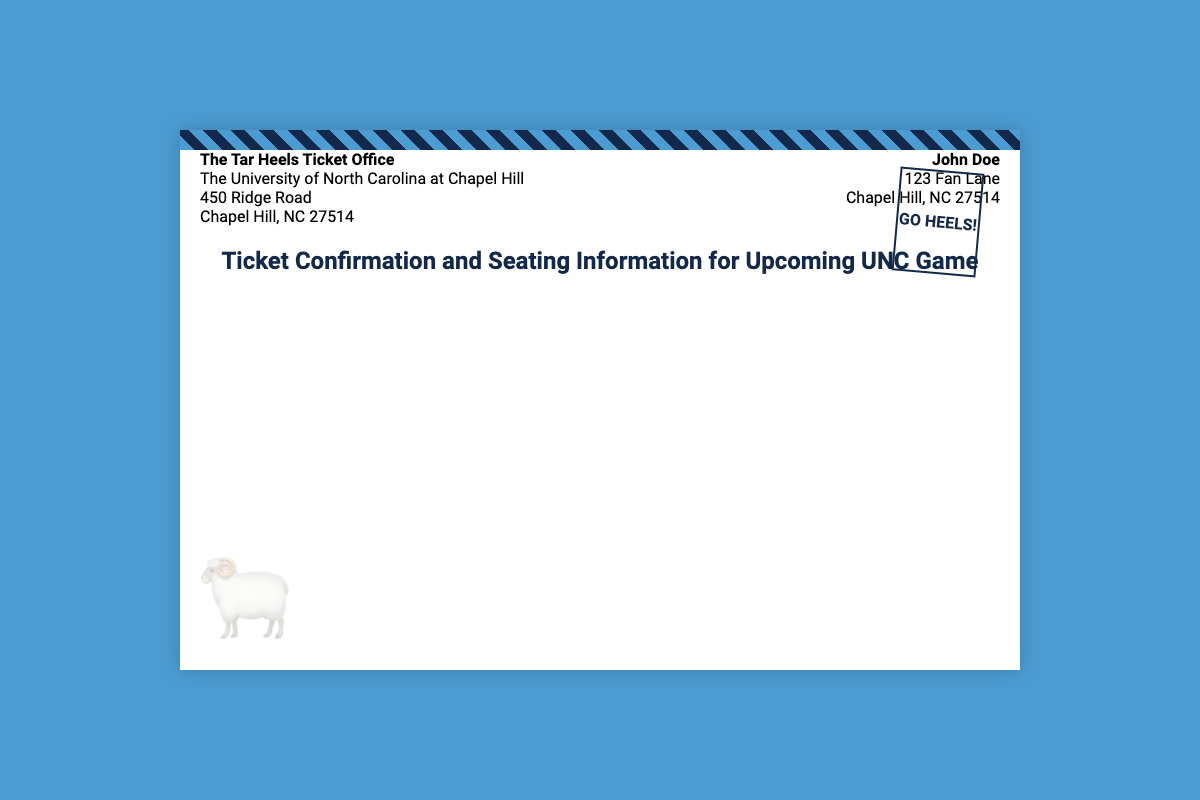What is the sender's title? The sender is identified as "The Tar Heels Ticket Office," which is the official title noted in the document.
Answer: The Tar Heels Ticket Office What is the recipient's name? The name of the person receiving the ticket is "John Doe," which is clearly stated in the address section of the document.
Answer: John Doe What is the address of the sender? The sender's address is specified as "450 Ridge Road, Chapel Hill, NC 27514," providing the location of the ticket office.
Answer: 450 Ridge Road, Chapel Hill, NC 27514 What phrase appears in the stamp? The stamp on the envelope reads "GO HEELS!" which is prominently placed for enthusiasm.
Answer: GO HEELS! What color is the background of the envelope? The background color of the envelope is "white," as described by the styling in the document.
Answer: white What decorative element is shown at the bottom of the envelope? The envelope features a logo at the bottom left, represented by an image of a ram, which is familiar to UNC fans.
Answer: logo of a ram What is the overall theme of the document? The document is themed around ticket confirmation and important information for an upcoming game, centered on supporting the University of North Carolina teams.
Answer: ticket confirmation and seating information What city is indicated in the recipient's address? The recipient's address includes "Chapel Hill," which is essential for delivery and a significant aspect to a UNC fan.
Answer: Chapel Hill 